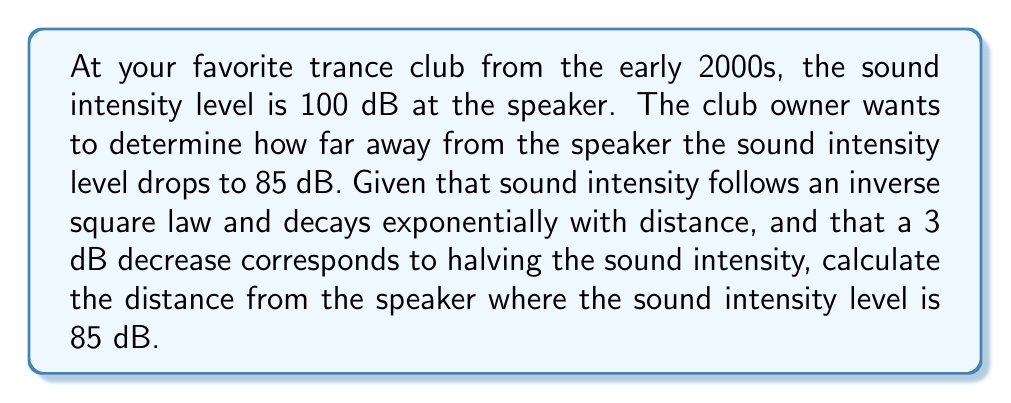What is the answer to this math problem? Let's approach this step-by-step:

1) First, we need to understand the relationship between decibels and intensity. The decibel scale is logarithmic, and a 3 dB decrease corresponds to halving the intensity.

2) We need to determine how many times the intensity has been halved to go from 100 dB to 85 dB.

3) The number of 3 dB decreases = $(100 - 85) / 3 = 5$

4) This means the intensity has been halved 5 times. We can express this mathematically as:

   $$\frac{1}{2^5} = \frac{1}{32}$$

5) Now, we know that intensity follows an inverse square law with distance. This means:

   $$I \propto \frac{1}{r^2}$$

   where $I$ is intensity and $r$ is distance.

6) Combining this with our halving, we get:

   $$\frac{1}{32} = \frac{1}{r^2}$$

7) Solving for $r$:

   $$r^2 = 32$$
   $$r = \sqrt{32} = 4\sqrt{2} \approx 5.66$$

8) Therefore, the distance at which the sound intensity level drops to 85 dB is approximately 5.66 times the reference distance (where it was 100 dB).
Answer: The sound intensity level drops to 85 dB at a distance of $4\sqrt{2} \approx 5.66$ times the reference distance from the speaker. 